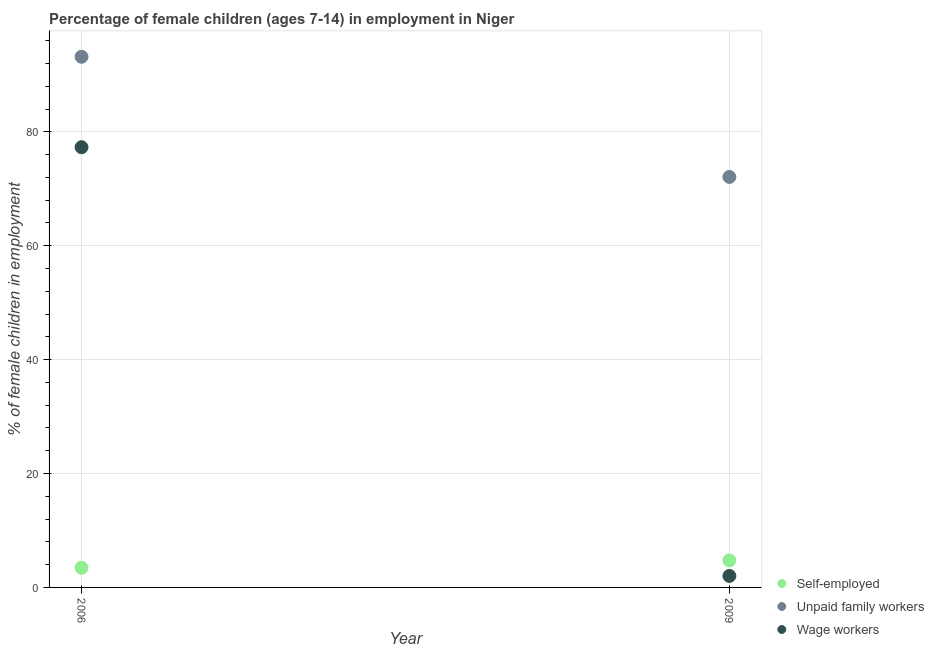How many different coloured dotlines are there?
Make the answer very short. 3. Is the number of dotlines equal to the number of legend labels?
Make the answer very short. Yes. What is the percentage of children employed as unpaid family workers in 2006?
Offer a very short reply. 93.18. Across all years, what is the maximum percentage of children employed as wage workers?
Keep it short and to the point. 77.3. Across all years, what is the minimum percentage of self employed children?
Make the answer very short. 3.46. In which year was the percentage of self employed children maximum?
Keep it short and to the point. 2009. In which year was the percentage of children employed as unpaid family workers minimum?
Provide a short and direct response. 2009. What is the total percentage of self employed children in the graph?
Your answer should be compact. 8.21. What is the difference between the percentage of self employed children in 2006 and that in 2009?
Give a very brief answer. -1.29. What is the difference between the percentage of self employed children in 2006 and the percentage of children employed as wage workers in 2009?
Keep it short and to the point. 1.44. What is the average percentage of children employed as unpaid family workers per year?
Keep it short and to the point. 82.63. In the year 2009, what is the difference between the percentage of children employed as wage workers and percentage of self employed children?
Ensure brevity in your answer.  -2.73. In how many years, is the percentage of children employed as unpaid family workers greater than 36 %?
Your answer should be very brief. 2. What is the ratio of the percentage of children employed as unpaid family workers in 2006 to that in 2009?
Make the answer very short. 1.29. Is the percentage of children employed as unpaid family workers in 2006 less than that in 2009?
Ensure brevity in your answer.  No. In how many years, is the percentage of self employed children greater than the average percentage of self employed children taken over all years?
Make the answer very short. 1. Is it the case that in every year, the sum of the percentage of self employed children and percentage of children employed as unpaid family workers is greater than the percentage of children employed as wage workers?
Your answer should be compact. Yes. Does the percentage of children employed as unpaid family workers monotonically increase over the years?
Your response must be concise. No. Is the percentage of self employed children strictly greater than the percentage of children employed as unpaid family workers over the years?
Make the answer very short. No. Is the percentage of children employed as wage workers strictly less than the percentage of children employed as unpaid family workers over the years?
Provide a succinct answer. Yes. How many dotlines are there?
Provide a short and direct response. 3. Are the values on the major ticks of Y-axis written in scientific E-notation?
Give a very brief answer. No. What is the title of the graph?
Your answer should be compact. Percentage of female children (ages 7-14) in employment in Niger. What is the label or title of the X-axis?
Ensure brevity in your answer.  Year. What is the label or title of the Y-axis?
Your answer should be very brief. % of female children in employment. What is the % of female children in employment of Self-employed in 2006?
Provide a short and direct response. 3.46. What is the % of female children in employment of Unpaid family workers in 2006?
Provide a succinct answer. 93.18. What is the % of female children in employment in Wage workers in 2006?
Keep it short and to the point. 77.3. What is the % of female children in employment of Self-employed in 2009?
Your answer should be very brief. 4.75. What is the % of female children in employment in Unpaid family workers in 2009?
Your answer should be compact. 72.08. What is the % of female children in employment in Wage workers in 2009?
Keep it short and to the point. 2.02. Across all years, what is the maximum % of female children in employment of Self-employed?
Keep it short and to the point. 4.75. Across all years, what is the maximum % of female children in employment in Unpaid family workers?
Keep it short and to the point. 93.18. Across all years, what is the maximum % of female children in employment of Wage workers?
Your response must be concise. 77.3. Across all years, what is the minimum % of female children in employment of Self-employed?
Your answer should be very brief. 3.46. Across all years, what is the minimum % of female children in employment in Unpaid family workers?
Offer a terse response. 72.08. Across all years, what is the minimum % of female children in employment in Wage workers?
Your answer should be compact. 2.02. What is the total % of female children in employment of Self-employed in the graph?
Offer a terse response. 8.21. What is the total % of female children in employment of Unpaid family workers in the graph?
Offer a terse response. 165.26. What is the total % of female children in employment of Wage workers in the graph?
Provide a short and direct response. 79.32. What is the difference between the % of female children in employment in Self-employed in 2006 and that in 2009?
Offer a very short reply. -1.29. What is the difference between the % of female children in employment in Unpaid family workers in 2006 and that in 2009?
Offer a very short reply. 21.1. What is the difference between the % of female children in employment of Wage workers in 2006 and that in 2009?
Your response must be concise. 75.28. What is the difference between the % of female children in employment in Self-employed in 2006 and the % of female children in employment in Unpaid family workers in 2009?
Your answer should be compact. -68.62. What is the difference between the % of female children in employment of Self-employed in 2006 and the % of female children in employment of Wage workers in 2009?
Offer a very short reply. 1.44. What is the difference between the % of female children in employment in Unpaid family workers in 2006 and the % of female children in employment in Wage workers in 2009?
Provide a short and direct response. 91.16. What is the average % of female children in employment in Self-employed per year?
Your response must be concise. 4.11. What is the average % of female children in employment in Unpaid family workers per year?
Make the answer very short. 82.63. What is the average % of female children in employment in Wage workers per year?
Keep it short and to the point. 39.66. In the year 2006, what is the difference between the % of female children in employment of Self-employed and % of female children in employment of Unpaid family workers?
Offer a very short reply. -89.72. In the year 2006, what is the difference between the % of female children in employment of Self-employed and % of female children in employment of Wage workers?
Offer a very short reply. -73.84. In the year 2006, what is the difference between the % of female children in employment in Unpaid family workers and % of female children in employment in Wage workers?
Your response must be concise. 15.88. In the year 2009, what is the difference between the % of female children in employment in Self-employed and % of female children in employment in Unpaid family workers?
Offer a terse response. -67.33. In the year 2009, what is the difference between the % of female children in employment of Self-employed and % of female children in employment of Wage workers?
Give a very brief answer. 2.73. In the year 2009, what is the difference between the % of female children in employment in Unpaid family workers and % of female children in employment in Wage workers?
Your answer should be compact. 70.06. What is the ratio of the % of female children in employment of Self-employed in 2006 to that in 2009?
Make the answer very short. 0.73. What is the ratio of the % of female children in employment of Unpaid family workers in 2006 to that in 2009?
Offer a terse response. 1.29. What is the ratio of the % of female children in employment in Wage workers in 2006 to that in 2009?
Give a very brief answer. 38.27. What is the difference between the highest and the second highest % of female children in employment of Self-employed?
Ensure brevity in your answer.  1.29. What is the difference between the highest and the second highest % of female children in employment in Unpaid family workers?
Offer a very short reply. 21.1. What is the difference between the highest and the second highest % of female children in employment in Wage workers?
Provide a succinct answer. 75.28. What is the difference between the highest and the lowest % of female children in employment in Self-employed?
Provide a short and direct response. 1.29. What is the difference between the highest and the lowest % of female children in employment of Unpaid family workers?
Your response must be concise. 21.1. What is the difference between the highest and the lowest % of female children in employment in Wage workers?
Provide a short and direct response. 75.28. 